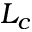Convert formula to latex. <formula><loc_0><loc_0><loc_500><loc_500>L _ { c }</formula> 